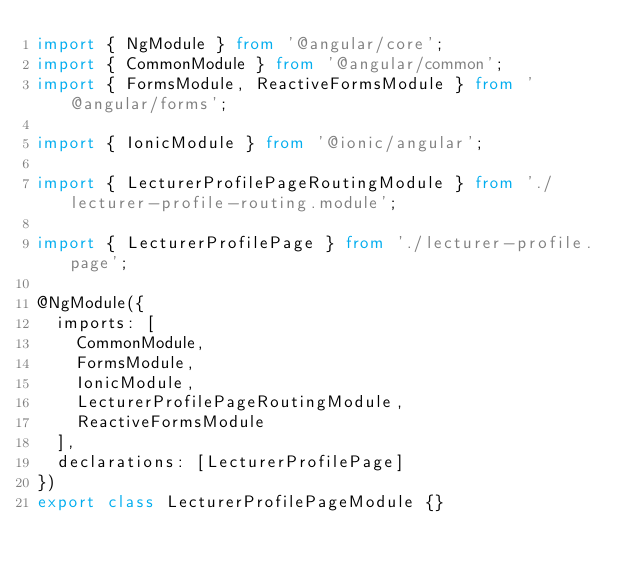<code> <loc_0><loc_0><loc_500><loc_500><_TypeScript_>import { NgModule } from '@angular/core';
import { CommonModule } from '@angular/common';
import { FormsModule, ReactiveFormsModule } from '@angular/forms';

import { IonicModule } from '@ionic/angular';

import { LecturerProfilePageRoutingModule } from './lecturer-profile-routing.module';

import { LecturerProfilePage } from './lecturer-profile.page';

@NgModule({
  imports: [
    CommonModule,
    FormsModule,
    IonicModule,
    LecturerProfilePageRoutingModule,
    ReactiveFormsModule
  ],
  declarations: [LecturerProfilePage]
})
export class LecturerProfilePageModule {}
</code> 